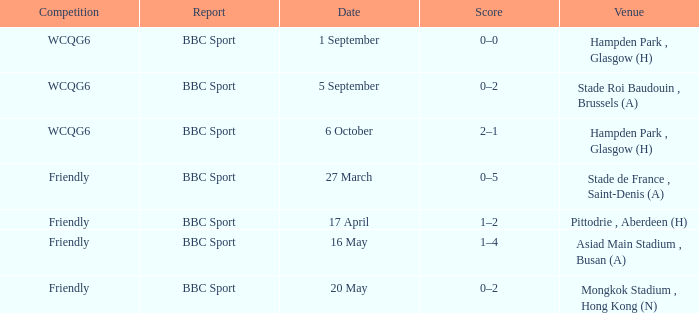Who reported the game played on 1 september? BBC Sport. 